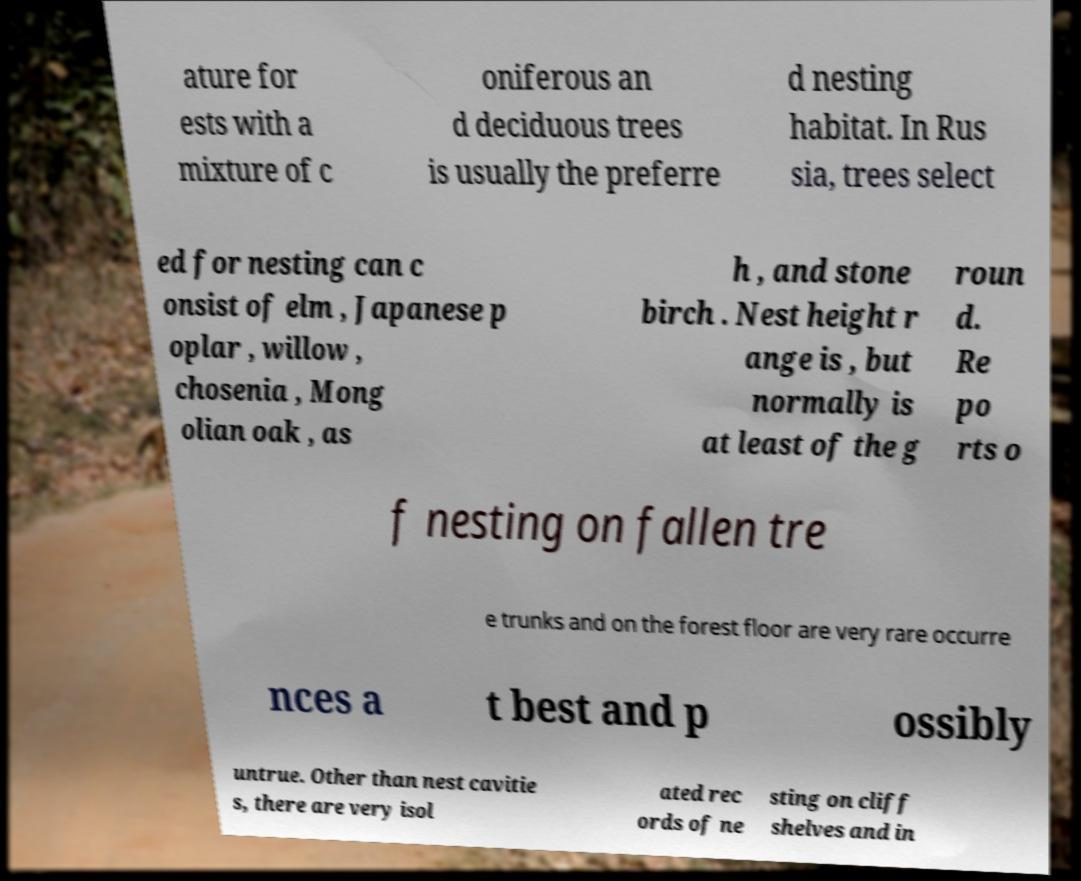There's text embedded in this image that I need extracted. Can you transcribe it verbatim? ature for ests with a mixture of c oniferous an d deciduous trees is usually the preferre d nesting habitat. In Rus sia, trees select ed for nesting can c onsist of elm , Japanese p oplar , willow , chosenia , Mong olian oak , as h , and stone birch . Nest height r ange is , but normally is at least of the g roun d. Re po rts o f nesting on fallen tre e trunks and on the forest floor are very rare occurre nces a t best and p ossibly untrue. Other than nest cavitie s, there are very isol ated rec ords of ne sting on cliff shelves and in 